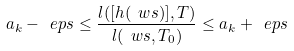Convert formula to latex. <formula><loc_0><loc_0><loc_500><loc_500>a _ { k } - \ e p s \leq \frac { l ( [ h ( \ w s ) ] , T ) } { l ( \ w s , T _ { 0 } ) } \leq a _ { k } + \ e p s</formula> 